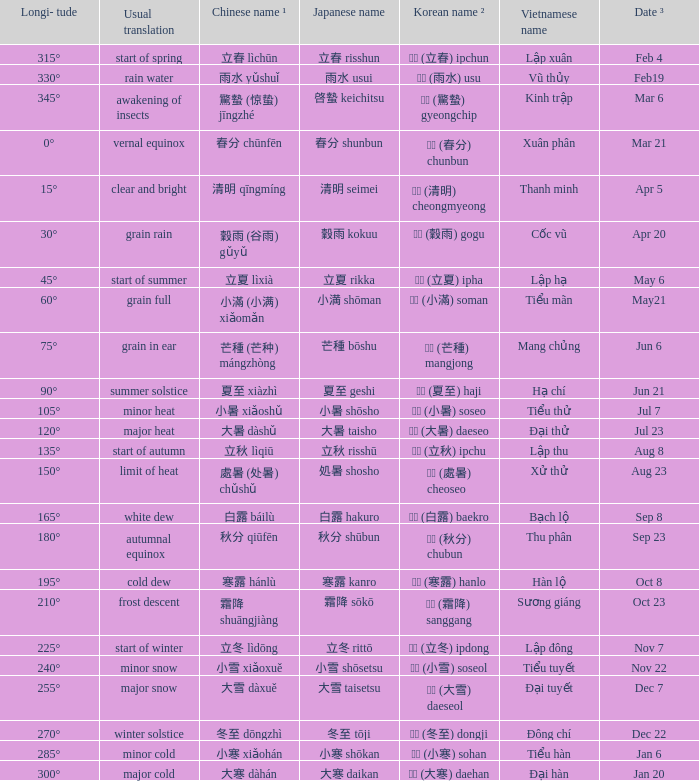When can a korean name ² of 청명 (清明) cheongmyeong be found? Apr 5. 